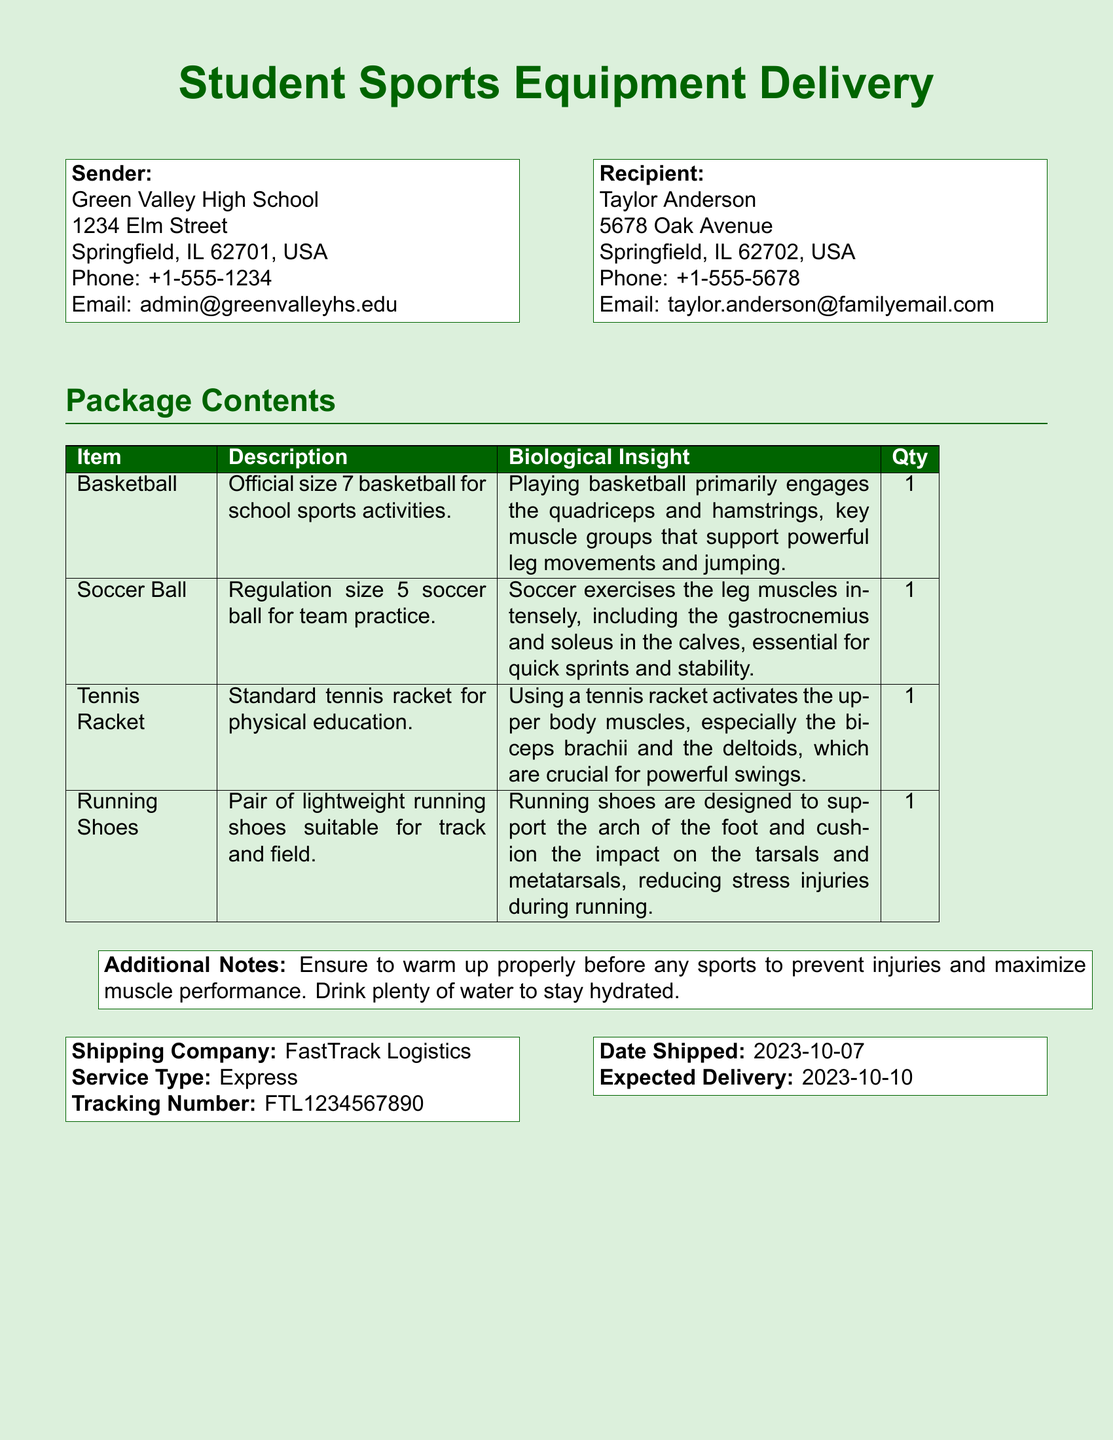What is the sender's address? The sender's address can be found in the "Sender" section of the document, which lists the address of Green Valley High School.
Answer: 1234 Elm Street, Springfield, IL 62701, USA What is the recipient's name? The recipient's name is stated directly in the "Recipient" section of the document.
Answer: Taylor Anderson What is the tracking number? The tracking number is found in the shipping company information section of the document.
Answer: FTL1234567890 How many items are listed in the package contents? The total number of items can be counted from the rows in the package contents table.
Answer: 4 What muscle groups does playing basketball engage? The biological insight for basketball lists key muscle groups involved in the activity.
Answer: Quadriceps and hamstrings What is the expected delivery date? The expected delivery date is provided in the shipping details section of the document.
Answer: 2023-10-10 What is the service type of shipping? The service type is mentioned in the shipping company information block as the method of delivery.
Answer: Express Which muscle is primarily engaged by using a tennis racket? The biological insight of the tennis racket specifies which muscle is primarily utilized.
Answer: Biceps brachii What should be done to prevent injuries before sports? The additional notes section provides advice on preventing injuries in sports.
Answer: Warm up properly 